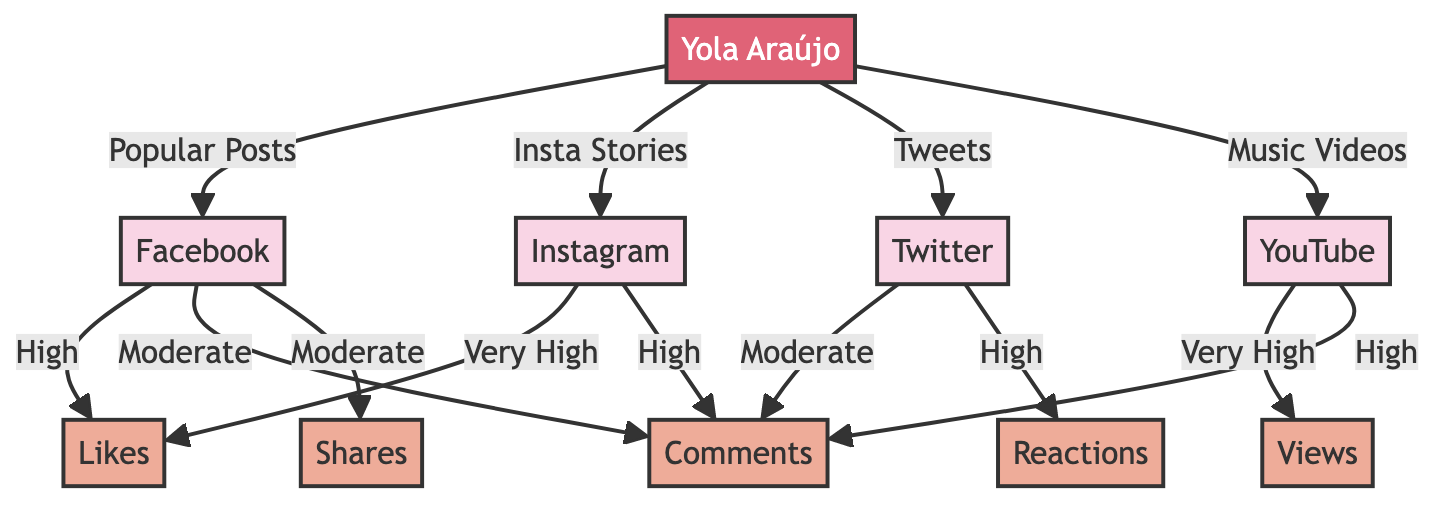How many social media platforms are represented in the diagram? The diagram includes five social media platforms: Facebook, Instagram, Twitter, and YouTube. Therefore, by counting these nodes, we find there are 4 platforms in total.
Answer: 4 What type of engagement is highest on Instagram? According to the diagram, Instagram shows a very high level of likes as the type of engagement listed for this platform.
Answer: Very High What is the engagement level for shares on Facebook? The diagram indicates that the engagement level for shares on Facebook is moderate, as denoted by the connection from Facebook to shares.
Answer: Moderate Which platform has the highest engagement for views? The diagram clearly indicates that YouTube has a very high engagement level for views, as shown in the connection from YouTube to views.
Answer: Very High What engagement type is listed for Twitter? The diagram shows two engagements for Twitter: moderate for comments and high for reactions. Both are valid answers depending on the context of the question.
Answer: Moderate (or High) What is the relationship between Yola Araújo and Facebook? The diagram illustrates that Yola Araújo connects to the Facebook platform through the popular posts interaction. This implies that Yola Araújo uses Facebook to share popular content with fans.
Answer: Popular Posts How many types of engagement are connected to YouTube? By examining the diagram, we see that YouTube is linked to two types of engagement: very high for views and high for shares. Therefore, there are 2 types of engagement associated with YouTube.
Answer: 2 Which platform generates the least amount of comments? The diagram indicates that Facebook has moderate comment engagement while Twitter also has moderate. However, since both have the same level, it could be said they tie for the least engagement type among the specified platforms.
Answer: Moderate What is the distinguished engagement type for Yola Araújo on YouTube? The diagram specifies that the distinguished engagement type for Yola Araújo on YouTube is very high for views, which is particularly notable compared to the other platforms.
Answer: Very High 